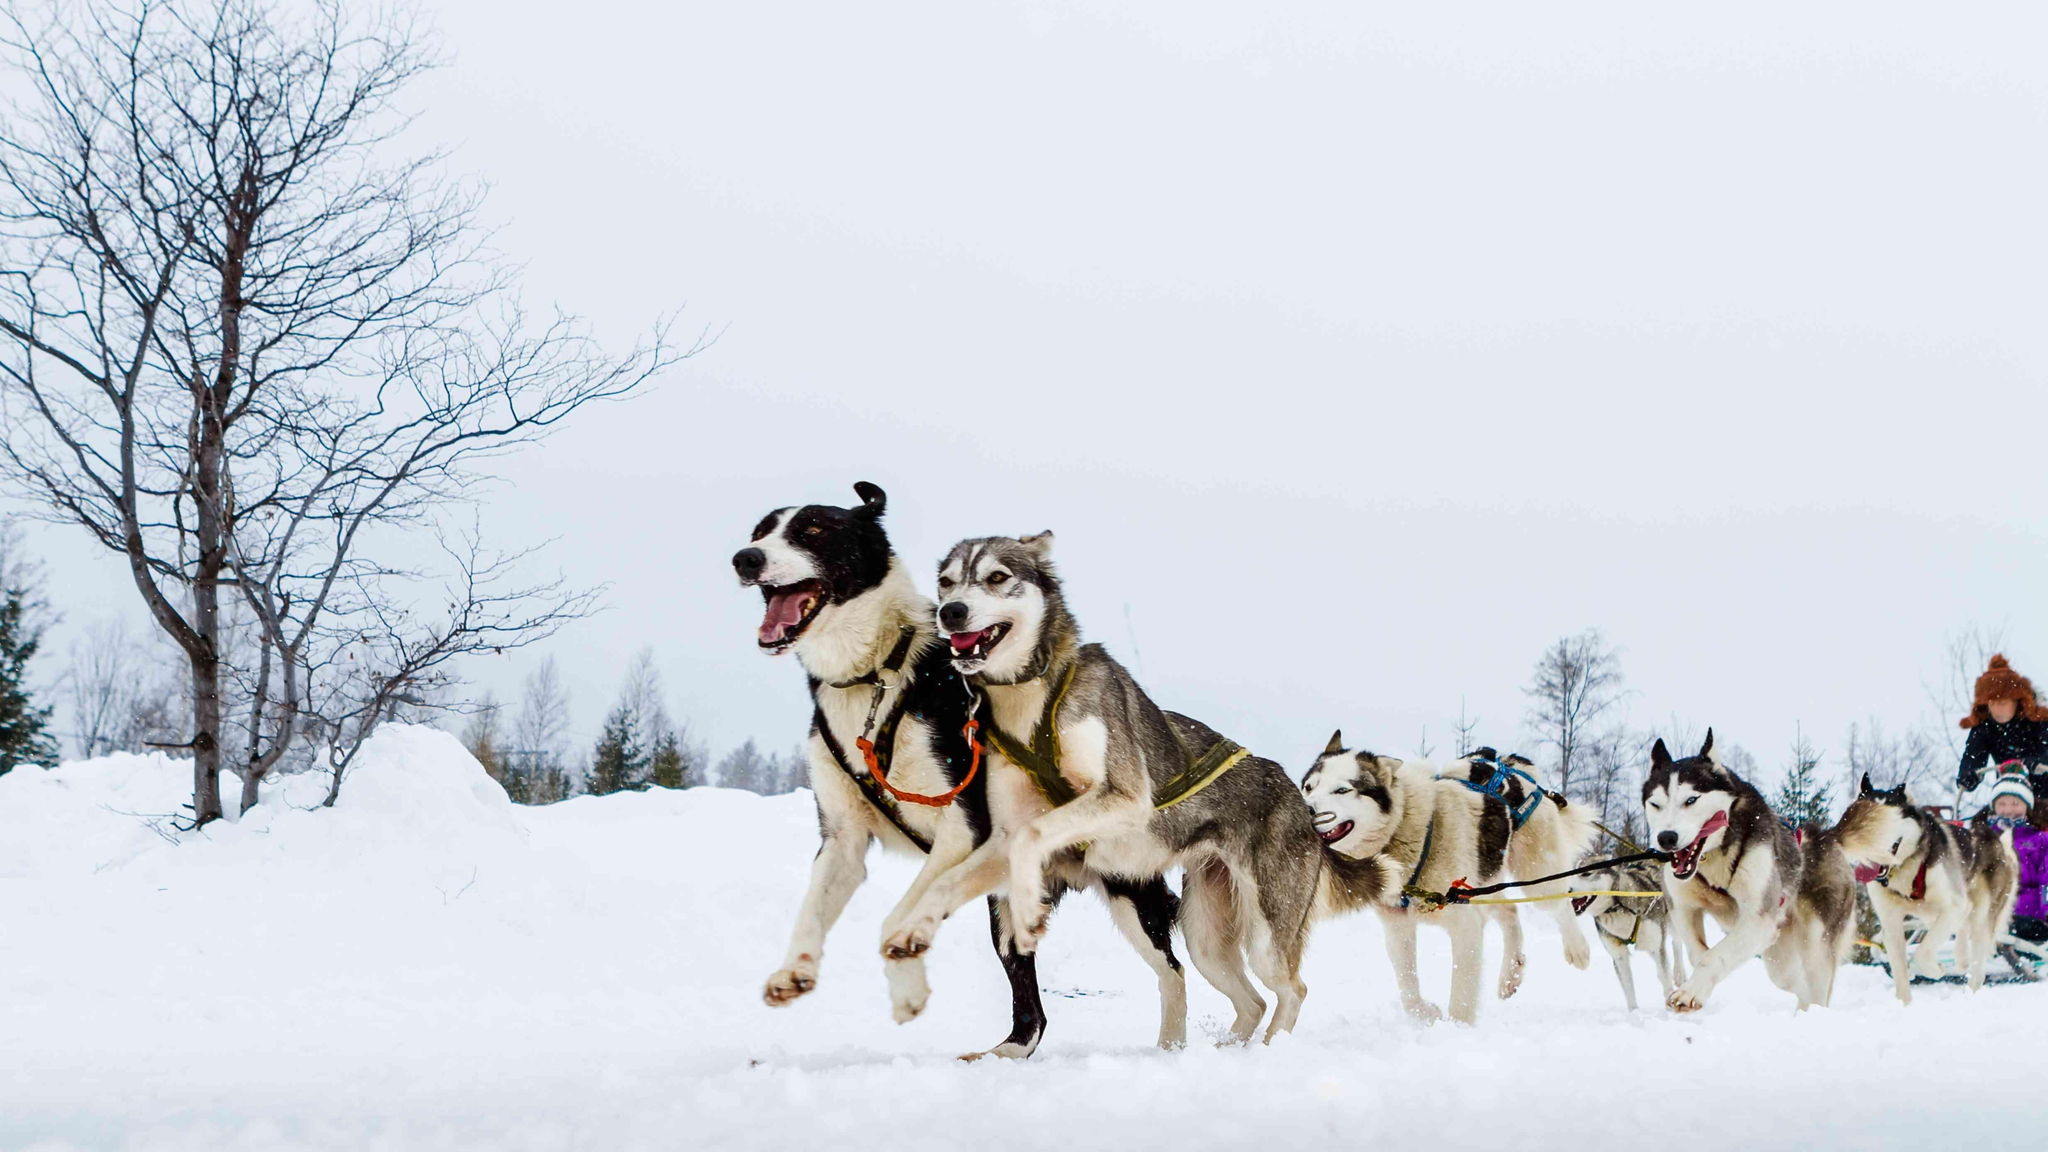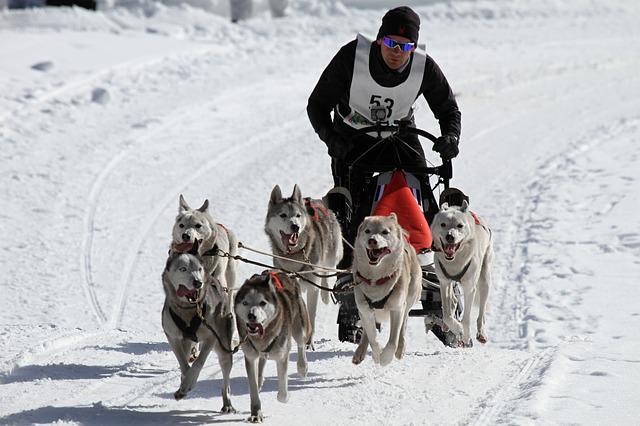The first image is the image on the left, the second image is the image on the right. Given the left and right images, does the statement "A person wearing a blue jacket is driving the sled." hold true? Answer yes or no. No. The first image is the image on the left, the second image is the image on the right. Considering the images on both sides, is "images are identical" valid? Answer yes or no. No. 